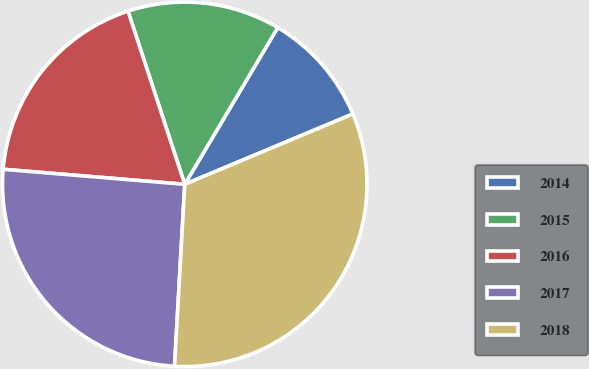<chart> <loc_0><loc_0><loc_500><loc_500><pie_chart><fcel>2014<fcel>2015<fcel>2016<fcel>2017<fcel>2018<nl><fcel>10.17%<fcel>13.56%<fcel>18.64%<fcel>25.42%<fcel>32.2%<nl></chart> 